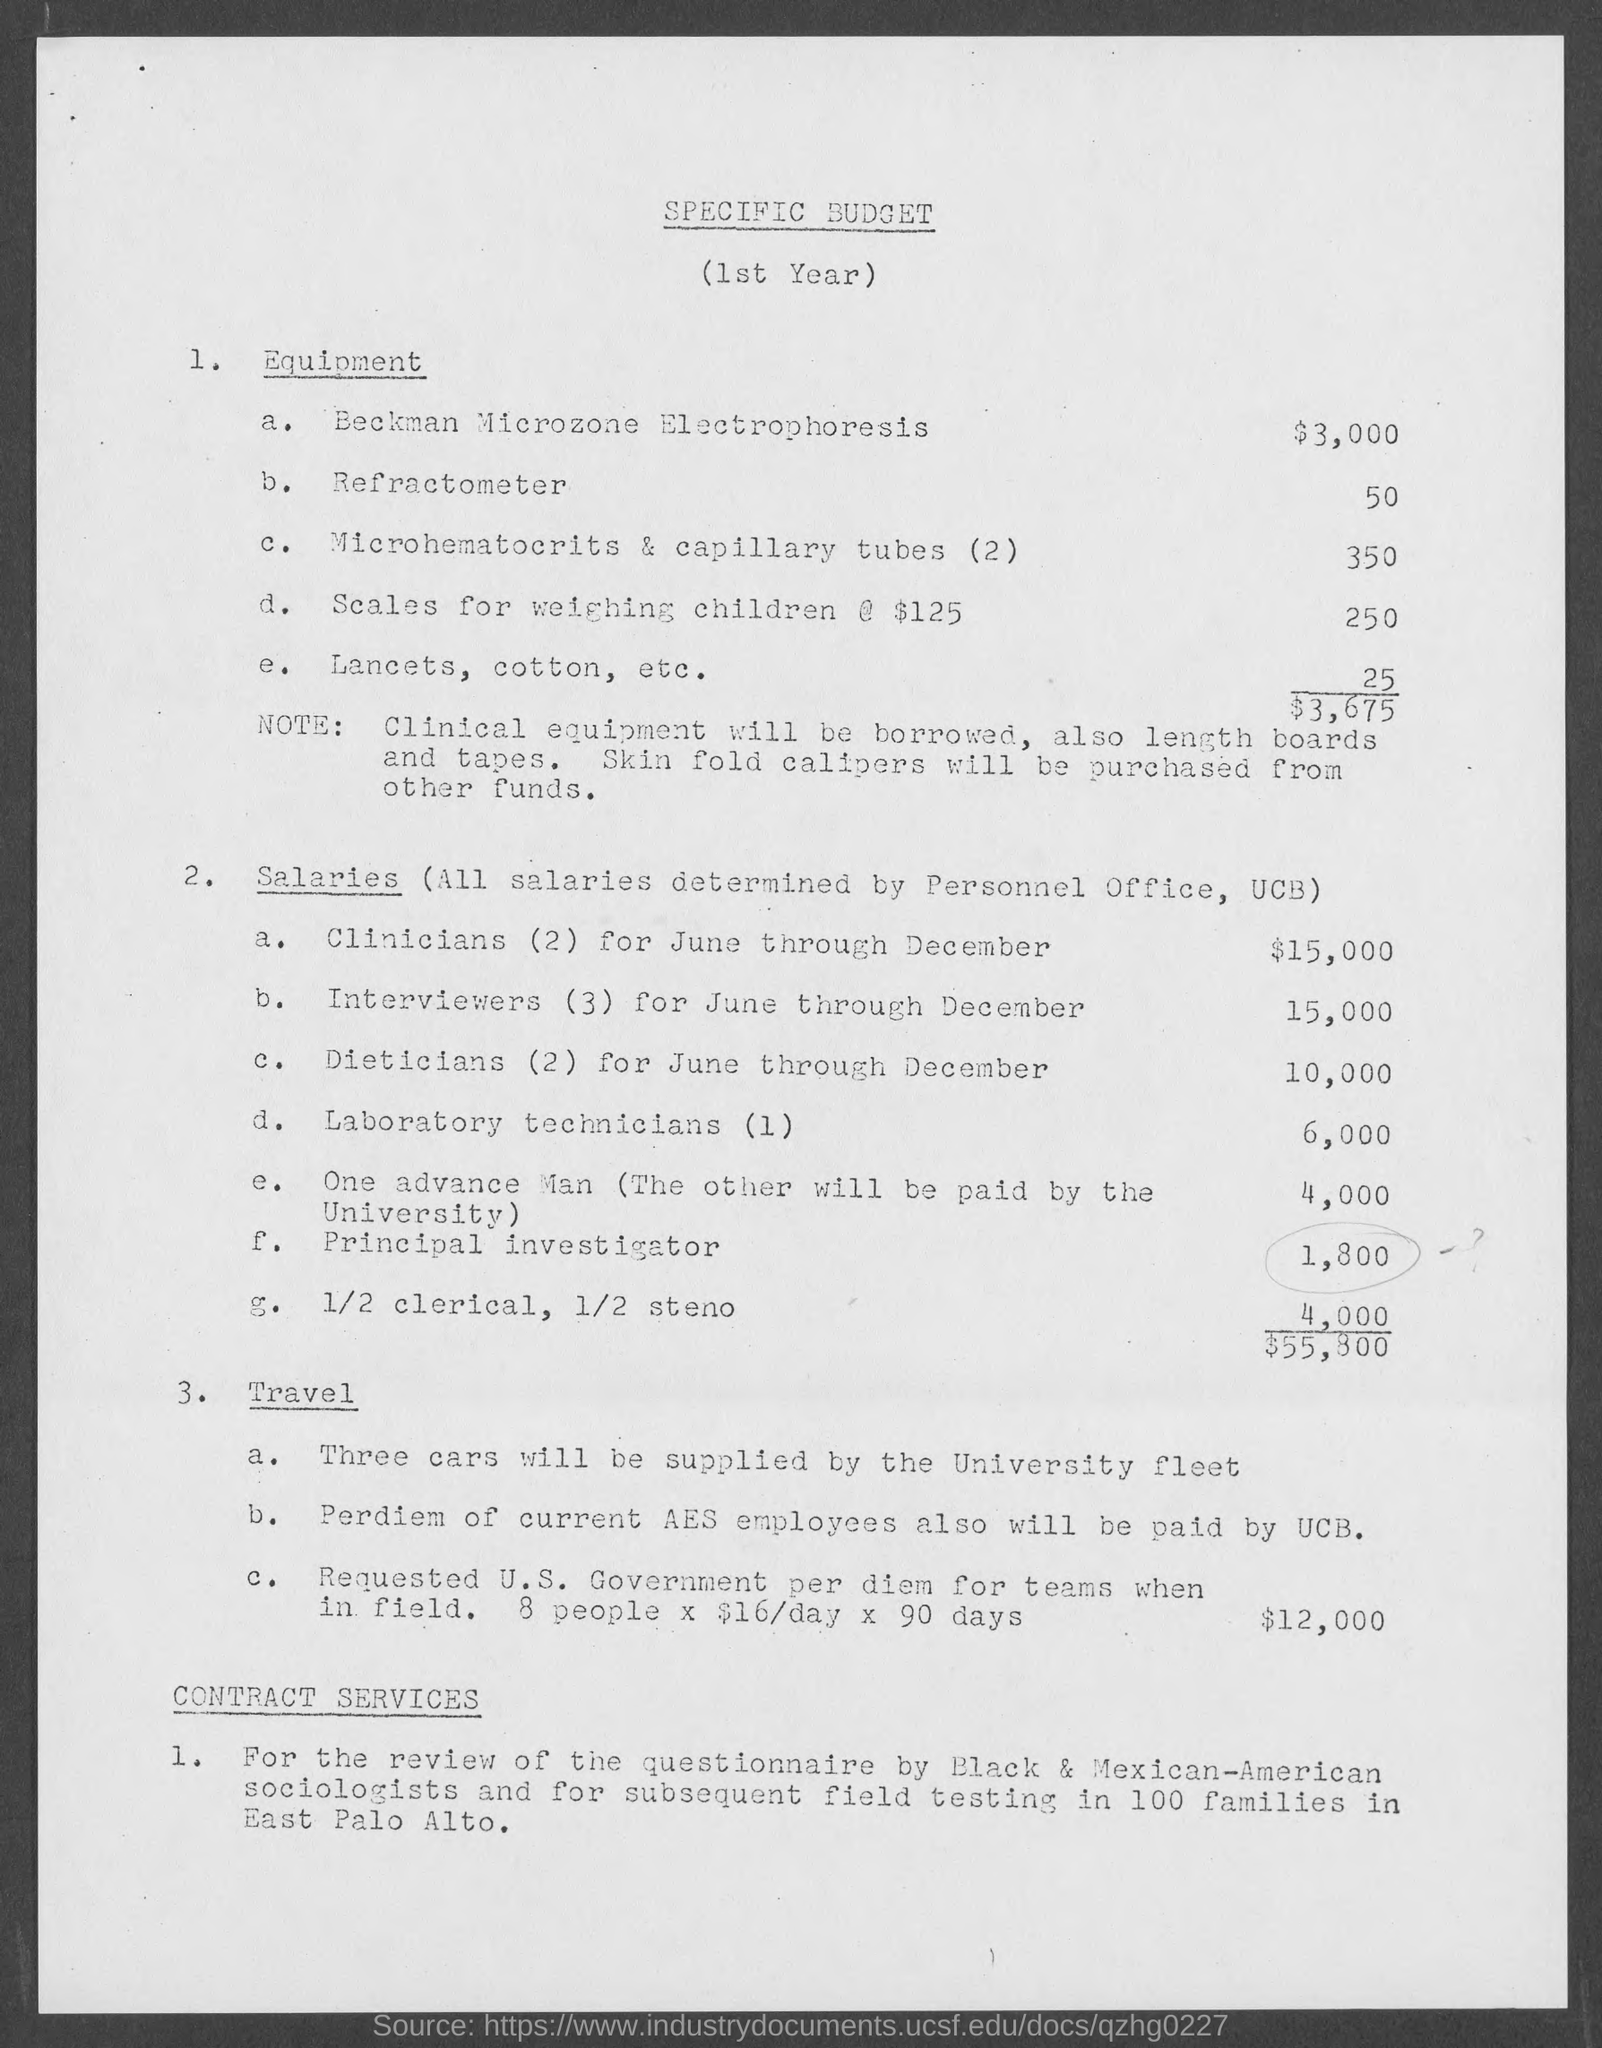What are the contract services described in this budget? The contract services mentioned in this budget pertain to the review of questionnaires by Black & Mexican-American sociologists and for subsequent field testing in 100 families in East Palo Alto. However, the document does not specify the costs associated with these services. 